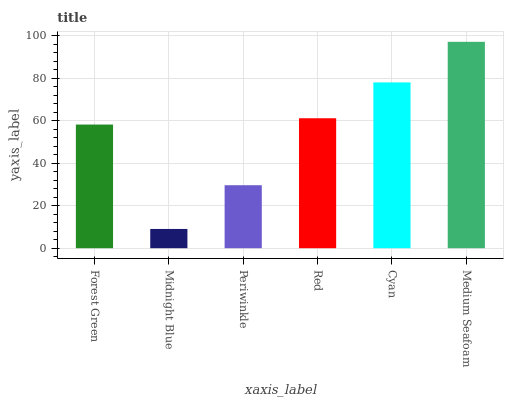Is Midnight Blue the minimum?
Answer yes or no. Yes. Is Medium Seafoam the maximum?
Answer yes or no. Yes. Is Periwinkle the minimum?
Answer yes or no. No. Is Periwinkle the maximum?
Answer yes or no. No. Is Periwinkle greater than Midnight Blue?
Answer yes or no. Yes. Is Midnight Blue less than Periwinkle?
Answer yes or no. Yes. Is Midnight Blue greater than Periwinkle?
Answer yes or no. No. Is Periwinkle less than Midnight Blue?
Answer yes or no. No. Is Red the high median?
Answer yes or no. Yes. Is Forest Green the low median?
Answer yes or no. Yes. Is Medium Seafoam the high median?
Answer yes or no. No. Is Midnight Blue the low median?
Answer yes or no. No. 